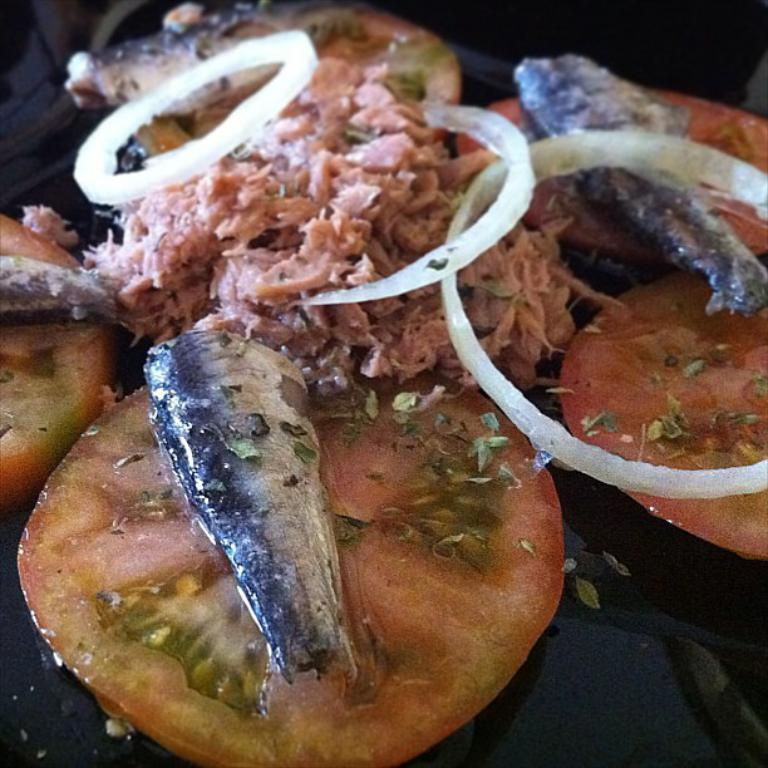What is the main subject of the image? The main subject of the image is food. What is the color of the table on which the food is placed? The table is black in color. Can you describe the color of the food? The food has a brown color. What type of flowers can be seen growing on the table in the image? There are no flowers present in the image; it features food on a black table. Can you hear the voice of the food in the image? The image is a visual representation and does not include any sounds or voices. 